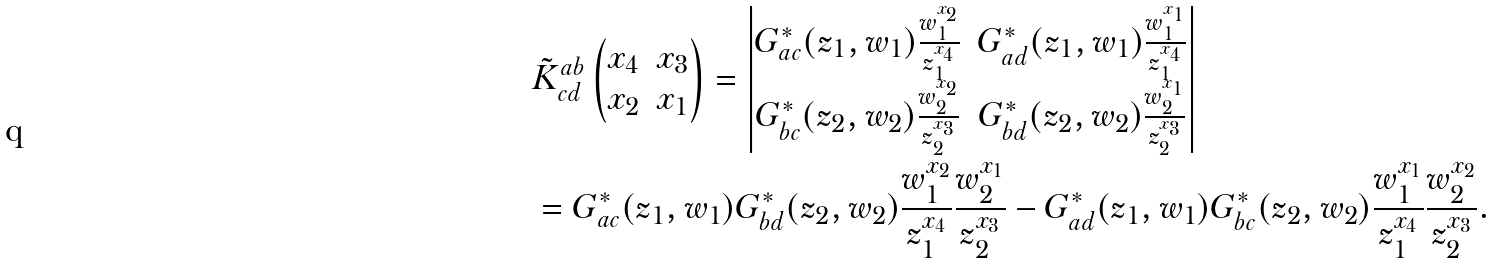<formula> <loc_0><loc_0><loc_500><loc_500>& \tilde { K } _ { c d } ^ { a b } \left ( \begin{matrix} x _ { 4 } & x _ { 3 } \\ x _ { 2 } & x _ { 1 } \end{matrix} \right ) = \left | \begin{matrix} G ^ { \ast } _ { a c } ( z _ { 1 } , w _ { 1 } ) \frac { w _ { 1 } ^ { x _ { 2 } } } { z _ { 1 } ^ { x _ { 4 } } } & G ^ { \ast } _ { a d } ( z _ { 1 } , w _ { 1 } ) \frac { w _ { 1 } ^ { x _ { 1 } } } { z _ { 1 } ^ { x _ { 4 } } } \\ G ^ { \ast } _ { b c } ( z _ { 2 } , w _ { 2 } ) \frac { w _ { 2 } ^ { x _ { 2 } } } { z _ { 2 } ^ { x _ { 3 } } } & G ^ { \ast } _ { b d } ( z _ { 2 } , w _ { 2 } ) \frac { w _ { 2 } ^ { x _ { 1 } } } { z _ { 2 } ^ { x _ { 3 } } } \end{matrix} \right | \\ & = G ^ { \ast } _ { a c } ( z _ { 1 } , w _ { 1 } ) G ^ { \ast } _ { b d } ( z _ { 2 } , w _ { 2 } ) \frac { w _ { 1 } ^ { x _ { 2 } } } { z _ { 1 } ^ { x _ { 4 } } } \frac { w _ { 2 } ^ { x _ { 1 } } } { z _ { 2 } ^ { x _ { 3 } } } - G ^ { \ast } _ { a d } ( z _ { 1 } , w _ { 1 } ) G ^ { \ast } _ { b c } ( z _ { 2 } , w _ { 2 } ) \frac { w _ { 1 } ^ { x _ { 1 } } } { z _ { 1 } ^ { x _ { 4 } } } \frac { w _ { 2 } ^ { x _ { 2 } } } { z _ { 2 } ^ { x _ { 3 } } } .</formula> 